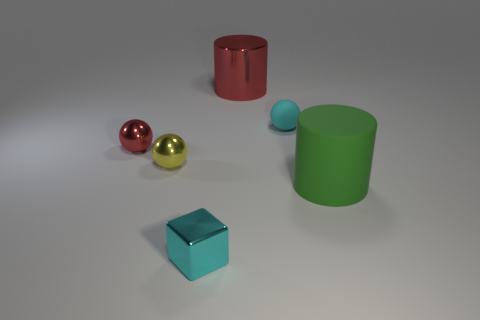Add 3 gray metallic cylinders. How many objects exist? 9 Subtract all cylinders. How many objects are left? 4 Subtract all cyan cubes. Subtract all cyan matte objects. How many objects are left? 4 Add 6 tiny red things. How many tiny red things are left? 7 Add 1 things. How many things exist? 7 Subtract 0 blue cubes. How many objects are left? 6 